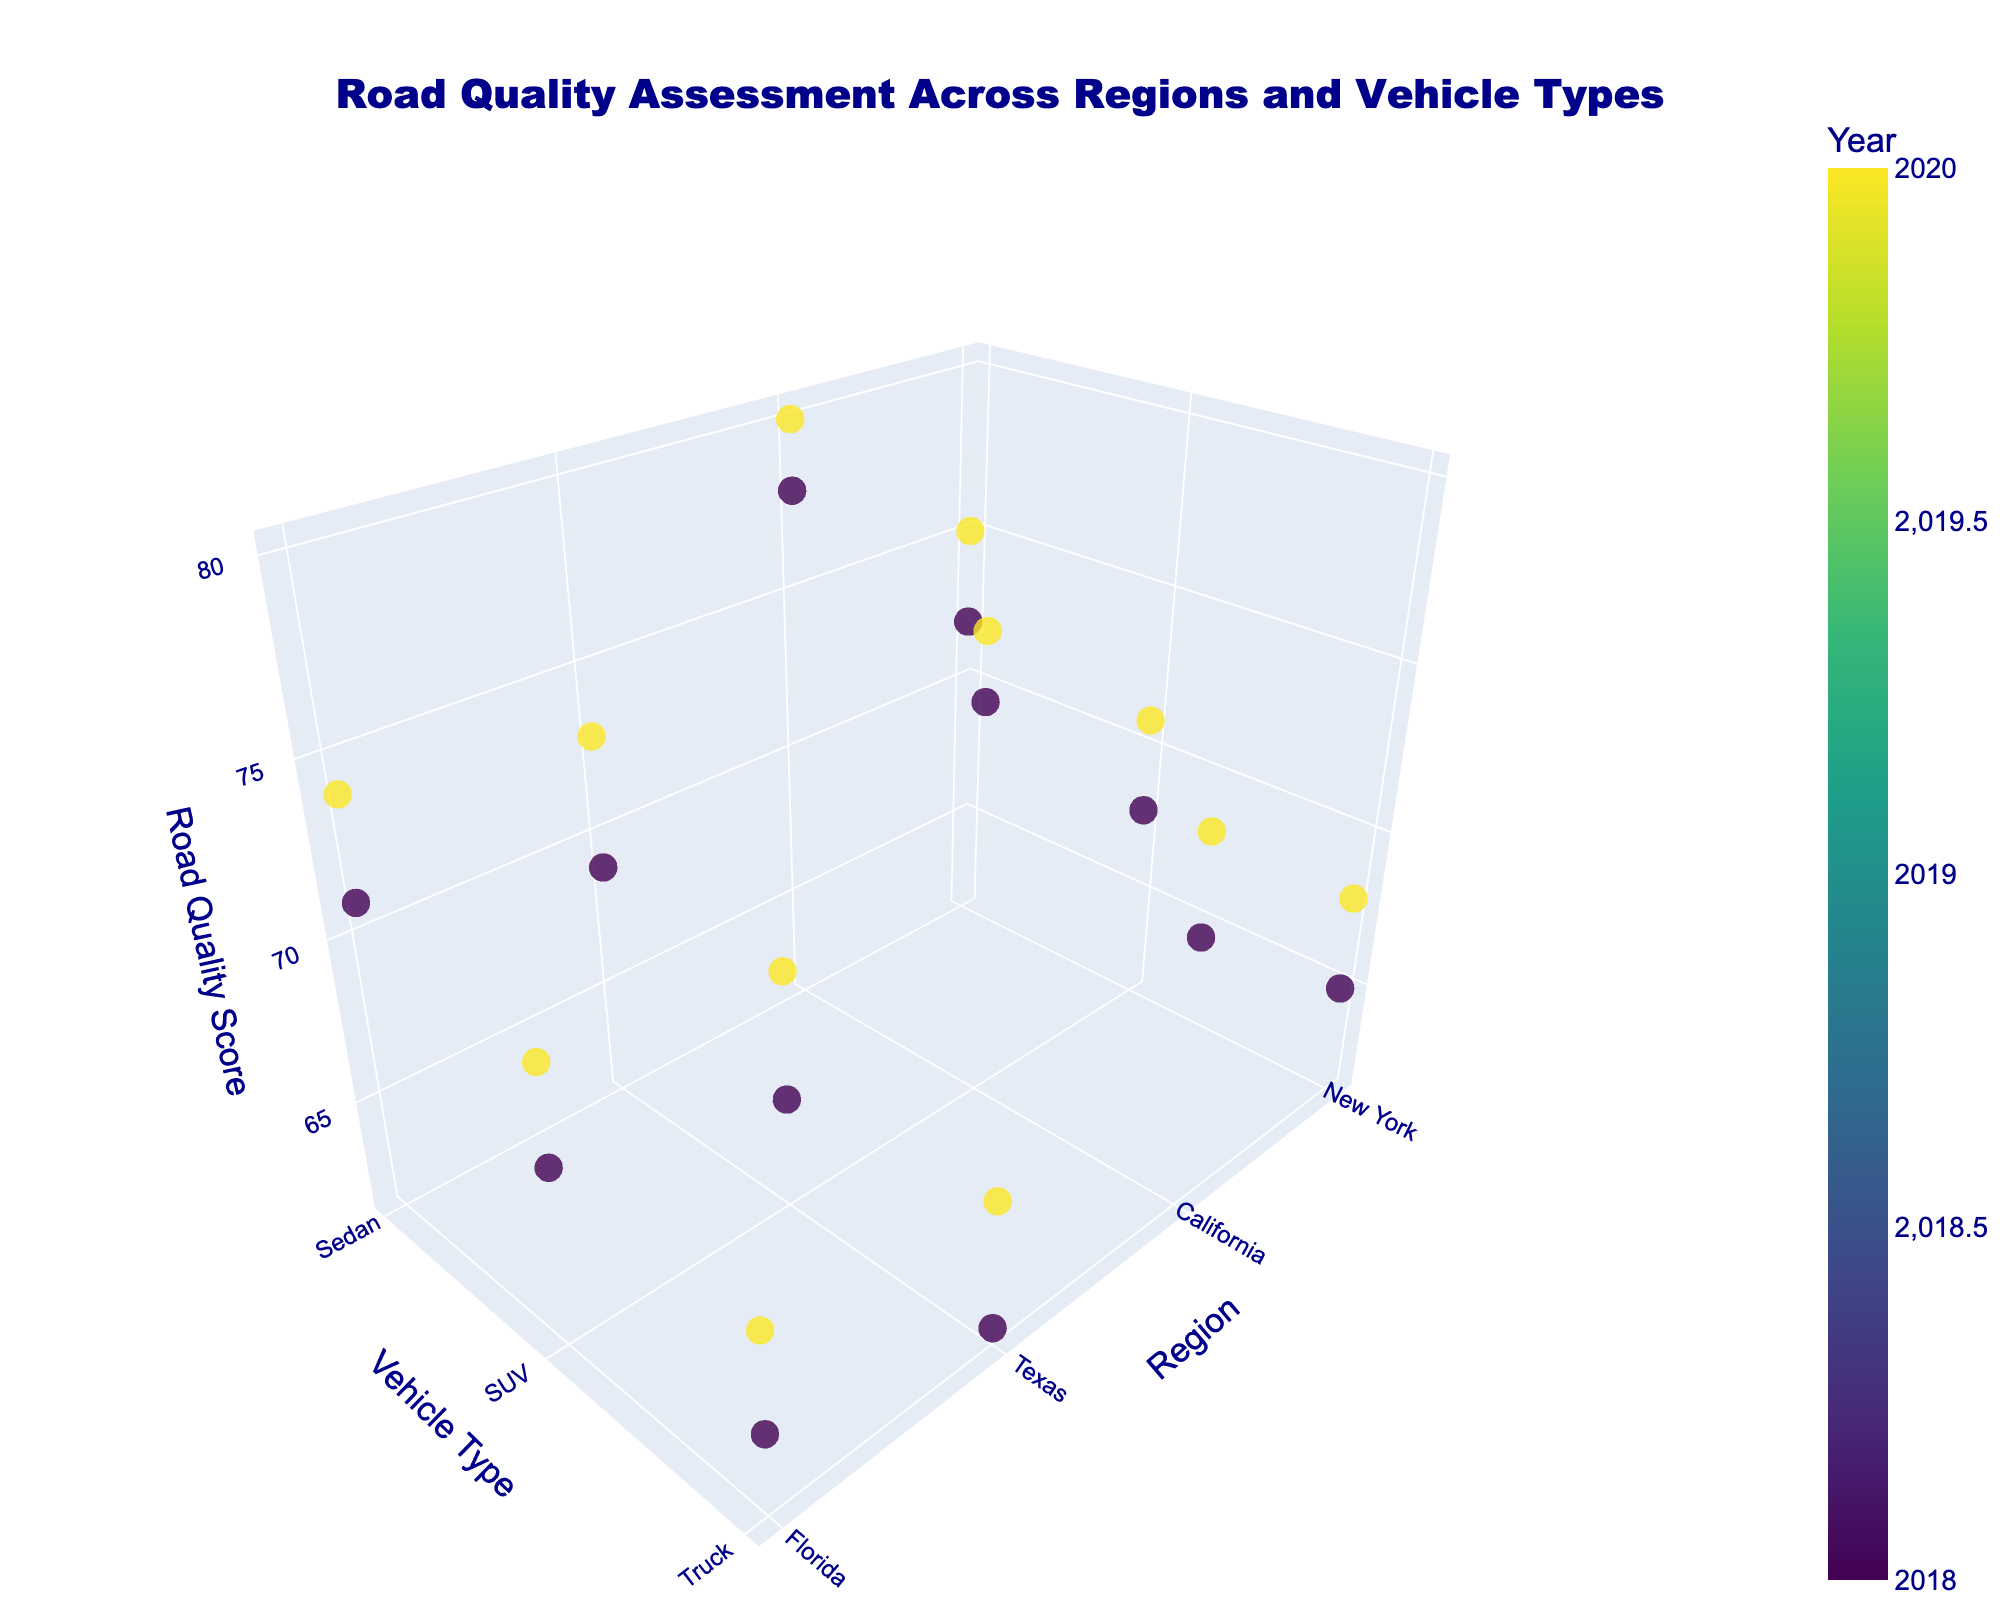What is the title of the figure? The title is clearly stated at the top of the figure and reads: "Road Quality Assessment Across Regions and Vehicle Types".
Answer: Road Quality Assessment Across Regions and Vehicle Types How many different regions are represented in the figure? The regions can be identified on the x-axis. Each spot on the x-axis represents a different region: New York, California, Texas, and Florida.
Answer: 4 Which color scale is used to represent the years in the figure? The color scale used is Viridis, which can be inferred from the colorbar on the right side of the figure indicating the variation across different years.
Answer: Viridis Which vehicle type in New York had the highest road quality score in 2020? By looking at the data points corresponding to "New York" on the x-axis and "2020" on the color scale, you can see that Sedans have the highest road quality score.
Answer: Sedan Between 2018 and 2020, how did the road quality score for Trucks in Texas change? Locate the data points for Trucks in Texas for both 2018 and 2020. In 2018, the score was 62, and in 2020, it increased to 66. The change is 66 - 62 = 4.
Answer: Increased by 4 Which combination of region and vehicle type had the lowest road quality score in 2018? By inspecting the data points with the lowest z-value in 2018 (indicated by the color scale), the lowest score is linked to Trucks in Texas with a score of 62.
Answer: Trucks in Texas Comparing Sedan vehicles, which region had the highest road quality score in 2020? Referencing the color scale for 2020 and looking at Sedan data points across regions, California had the highest score for Sedans with a score of 80.
Answer: California What is the average road quality score for SUVs in Florida across the two years? Identify the scores for SUVs in Florida: 67 in 2018 and 70 in 2020. The average is (67 + 70) / 2 = 68.5.
Answer: 68.5 According to the figure, which year generally had better road quality scores across all regions and vehicle types? By examining the data points' colors, data points representing the year 2020 (in shades corresponding to higher color values on the Viridis scale) show consistently higher road quality scores than 2018.
Answer: 2020 Are there any overlapping points where road quality scores for different vehicle types and the same region and year are identical? By visually inspecting closely clustered data points for the same region and year, there do not appear to be any exact overlaps indicating identical scores.
Answer: No 